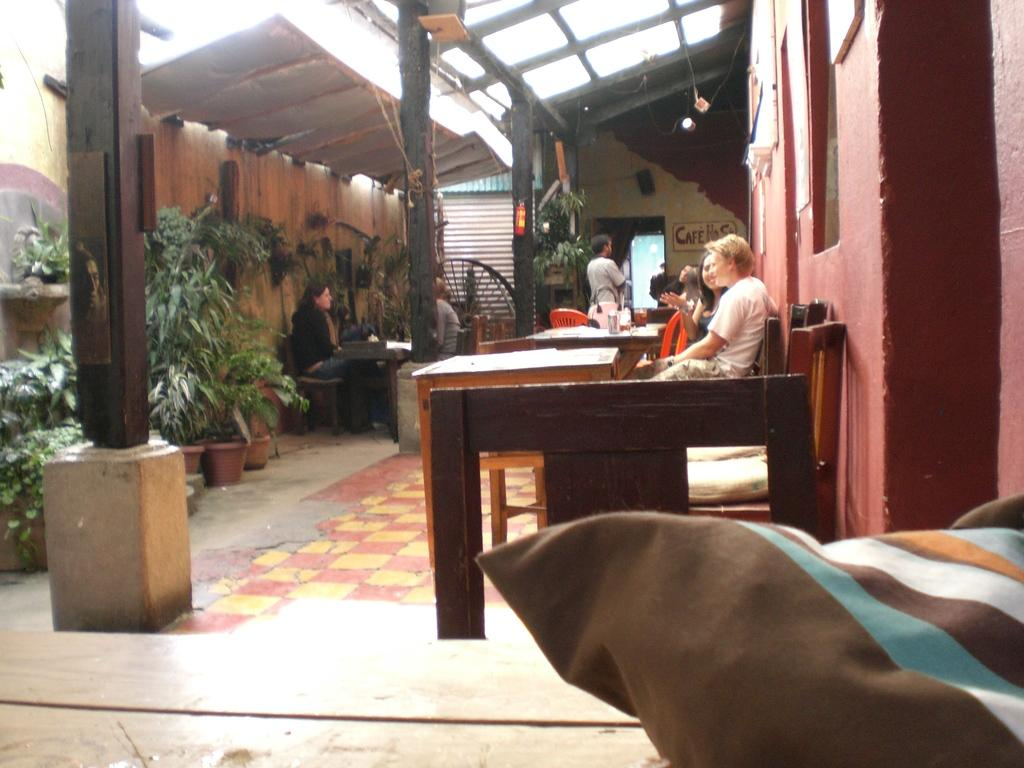What are the people in the image doing? The people in the image are sitting on chairs. What objects are in front of the chairs? There are tables in front of the chairs. What can be seen on the right side of the image? There is a red wall on the right side of the image. What type of vegetation is on the left side of the image? There are plants on the left side of the image. How many balloons are floating above the people in the image? There are no balloons present in the image. What type of scissors are being used by the people in the image? There is no mention of scissors or any cutting activity in the image. 